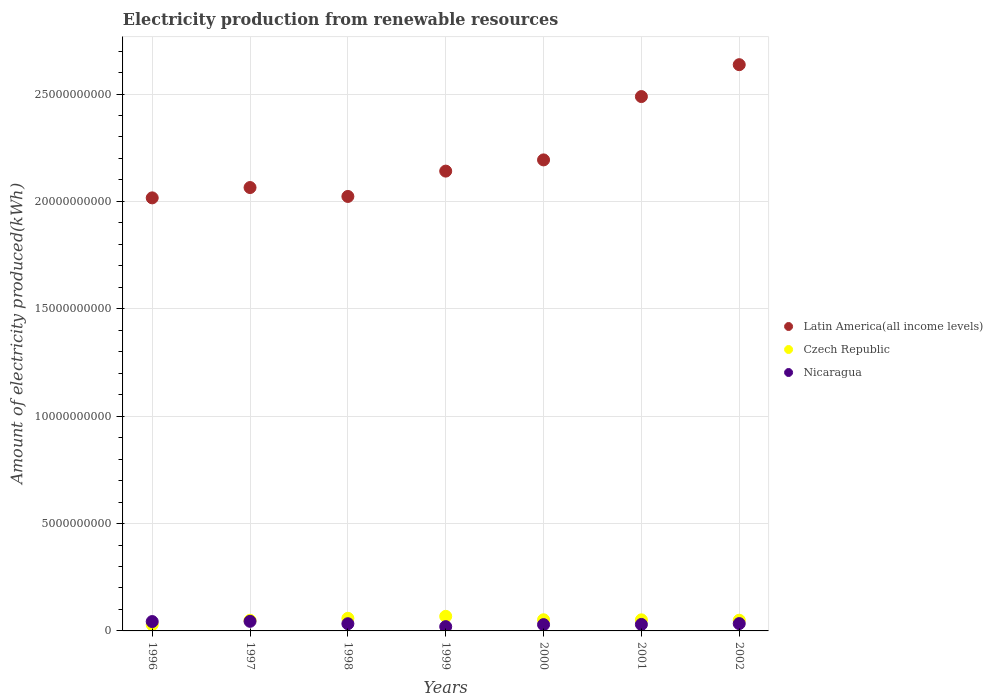What is the amount of electricity produced in Latin America(all income levels) in 1999?
Make the answer very short. 2.14e+1. Across all years, what is the maximum amount of electricity produced in Czech Republic?
Offer a terse response. 6.79e+08. Across all years, what is the minimum amount of electricity produced in Czech Republic?
Keep it short and to the point. 2.92e+08. In which year was the amount of electricity produced in Czech Republic maximum?
Keep it short and to the point. 1999. What is the total amount of electricity produced in Nicaragua in the graph?
Your answer should be compact. 2.35e+09. What is the difference between the amount of electricity produced in Latin America(all income levels) in 1999 and that in 2000?
Make the answer very short. -5.22e+08. What is the difference between the amount of electricity produced in Latin America(all income levels) in 2002 and the amount of electricity produced in Czech Republic in 1997?
Provide a succinct answer. 2.59e+1. What is the average amount of electricity produced in Nicaragua per year?
Give a very brief answer. 3.36e+08. In the year 1997, what is the difference between the amount of electricity produced in Latin America(all income levels) and amount of electricity produced in Nicaragua?
Your answer should be very brief. 2.02e+1. In how many years, is the amount of electricity produced in Latin America(all income levels) greater than 24000000000 kWh?
Your answer should be compact. 2. What is the ratio of the amount of electricity produced in Czech Republic in 1996 to that in 1997?
Give a very brief answer. 0.59. Is the amount of electricity produced in Latin America(all income levels) in 1997 less than that in 1999?
Keep it short and to the point. Yes. Is the difference between the amount of electricity produced in Latin America(all income levels) in 2000 and 2002 greater than the difference between the amount of electricity produced in Nicaragua in 2000 and 2002?
Provide a short and direct response. No. What is the difference between the highest and the second highest amount of electricity produced in Latin America(all income levels)?
Provide a short and direct response. 1.48e+09. What is the difference between the highest and the lowest amount of electricity produced in Latin America(all income levels)?
Keep it short and to the point. 6.20e+09. In how many years, is the amount of electricity produced in Nicaragua greater than the average amount of electricity produced in Nicaragua taken over all years?
Make the answer very short. 3. Is the sum of the amount of electricity produced in Czech Republic in 1996 and 1997 greater than the maximum amount of electricity produced in Latin America(all income levels) across all years?
Give a very brief answer. No. Does the amount of electricity produced in Nicaragua monotonically increase over the years?
Your response must be concise. No. Is the amount of electricity produced in Latin America(all income levels) strictly greater than the amount of electricity produced in Czech Republic over the years?
Make the answer very short. Yes. Is the amount of electricity produced in Nicaragua strictly less than the amount of electricity produced in Latin America(all income levels) over the years?
Your response must be concise. Yes. What is the difference between two consecutive major ticks on the Y-axis?
Keep it short and to the point. 5.00e+09. Where does the legend appear in the graph?
Make the answer very short. Center right. How many legend labels are there?
Provide a short and direct response. 3. How are the legend labels stacked?
Give a very brief answer. Vertical. What is the title of the graph?
Make the answer very short. Electricity production from renewable resources. What is the label or title of the Y-axis?
Make the answer very short. Amount of electricity produced(kWh). What is the Amount of electricity produced(kWh) in Latin America(all income levels) in 1996?
Your answer should be compact. 2.02e+1. What is the Amount of electricity produced(kWh) in Czech Republic in 1996?
Your response must be concise. 2.92e+08. What is the Amount of electricity produced(kWh) of Nicaragua in 1996?
Give a very brief answer. 4.36e+08. What is the Amount of electricity produced(kWh) of Latin America(all income levels) in 1997?
Offer a very short reply. 2.06e+1. What is the Amount of electricity produced(kWh) in Czech Republic in 1997?
Your response must be concise. 4.94e+08. What is the Amount of electricity produced(kWh) of Nicaragua in 1997?
Give a very brief answer. 4.47e+08. What is the Amount of electricity produced(kWh) of Latin America(all income levels) in 1998?
Your response must be concise. 2.02e+1. What is the Amount of electricity produced(kWh) of Czech Republic in 1998?
Your answer should be compact. 5.87e+08. What is the Amount of electricity produced(kWh) of Nicaragua in 1998?
Give a very brief answer. 3.35e+08. What is the Amount of electricity produced(kWh) of Latin America(all income levels) in 1999?
Your response must be concise. 2.14e+1. What is the Amount of electricity produced(kWh) in Czech Republic in 1999?
Provide a short and direct response. 6.79e+08. What is the Amount of electricity produced(kWh) in Latin America(all income levels) in 2000?
Keep it short and to the point. 2.19e+1. What is the Amount of electricity produced(kWh) in Czech Republic in 2000?
Offer a terse response. 5.19e+08. What is the Amount of electricity produced(kWh) of Nicaragua in 2000?
Your answer should be very brief. 2.93e+08. What is the Amount of electricity produced(kWh) in Latin America(all income levels) in 2001?
Your answer should be compact. 2.49e+1. What is the Amount of electricity produced(kWh) of Czech Republic in 2001?
Make the answer very short. 5.16e+08. What is the Amount of electricity produced(kWh) of Nicaragua in 2001?
Offer a very short reply. 3.02e+08. What is the Amount of electricity produced(kWh) in Latin America(all income levels) in 2002?
Give a very brief answer. 2.64e+1. What is the Amount of electricity produced(kWh) in Czech Republic in 2002?
Offer a terse response. 4.98e+08. What is the Amount of electricity produced(kWh) in Nicaragua in 2002?
Offer a terse response. 3.41e+08. Across all years, what is the maximum Amount of electricity produced(kWh) in Latin America(all income levels)?
Your answer should be compact. 2.64e+1. Across all years, what is the maximum Amount of electricity produced(kWh) in Czech Republic?
Keep it short and to the point. 6.79e+08. Across all years, what is the maximum Amount of electricity produced(kWh) of Nicaragua?
Give a very brief answer. 4.47e+08. Across all years, what is the minimum Amount of electricity produced(kWh) of Latin America(all income levels)?
Give a very brief answer. 2.02e+1. Across all years, what is the minimum Amount of electricity produced(kWh) of Czech Republic?
Your answer should be compact. 2.92e+08. Across all years, what is the minimum Amount of electricity produced(kWh) in Nicaragua?
Your answer should be compact. 2.00e+08. What is the total Amount of electricity produced(kWh) in Latin America(all income levels) in the graph?
Provide a succinct answer. 1.56e+11. What is the total Amount of electricity produced(kWh) of Czech Republic in the graph?
Provide a succinct answer. 3.58e+09. What is the total Amount of electricity produced(kWh) in Nicaragua in the graph?
Your response must be concise. 2.35e+09. What is the difference between the Amount of electricity produced(kWh) of Latin America(all income levels) in 1996 and that in 1997?
Ensure brevity in your answer.  -4.81e+08. What is the difference between the Amount of electricity produced(kWh) of Czech Republic in 1996 and that in 1997?
Provide a short and direct response. -2.02e+08. What is the difference between the Amount of electricity produced(kWh) of Nicaragua in 1996 and that in 1997?
Keep it short and to the point. -1.10e+07. What is the difference between the Amount of electricity produced(kWh) of Latin America(all income levels) in 1996 and that in 1998?
Give a very brief answer. -6.60e+07. What is the difference between the Amount of electricity produced(kWh) in Czech Republic in 1996 and that in 1998?
Give a very brief answer. -2.95e+08. What is the difference between the Amount of electricity produced(kWh) in Nicaragua in 1996 and that in 1998?
Your response must be concise. 1.01e+08. What is the difference between the Amount of electricity produced(kWh) in Latin America(all income levels) in 1996 and that in 1999?
Offer a very short reply. -1.25e+09. What is the difference between the Amount of electricity produced(kWh) of Czech Republic in 1996 and that in 1999?
Your response must be concise. -3.87e+08. What is the difference between the Amount of electricity produced(kWh) of Nicaragua in 1996 and that in 1999?
Provide a succinct answer. 2.36e+08. What is the difference between the Amount of electricity produced(kWh) in Latin America(all income levels) in 1996 and that in 2000?
Your answer should be compact. -1.77e+09. What is the difference between the Amount of electricity produced(kWh) of Czech Republic in 1996 and that in 2000?
Offer a terse response. -2.27e+08. What is the difference between the Amount of electricity produced(kWh) in Nicaragua in 1996 and that in 2000?
Provide a short and direct response. 1.43e+08. What is the difference between the Amount of electricity produced(kWh) of Latin America(all income levels) in 1996 and that in 2001?
Provide a short and direct response. -4.72e+09. What is the difference between the Amount of electricity produced(kWh) of Czech Republic in 1996 and that in 2001?
Offer a very short reply. -2.24e+08. What is the difference between the Amount of electricity produced(kWh) in Nicaragua in 1996 and that in 2001?
Your response must be concise. 1.34e+08. What is the difference between the Amount of electricity produced(kWh) of Latin America(all income levels) in 1996 and that in 2002?
Keep it short and to the point. -6.20e+09. What is the difference between the Amount of electricity produced(kWh) of Czech Republic in 1996 and that in 2002?
Provide a succinct answer. -2.06e+08. What is the difference between the Amount of electricity produced(kWh) in Nicaragua in 1996 and that in 2002?
Provide a succinct answer. 9.50e+07. What is the difference between the Amount of electricity produced(kWh) of Latin America(all income levels) in 1997 and that in 1998?
Offer a very short reply. 4.15e+08. What is the difference between the Amount of electricity produced(kWh) in Czech Republic in 1997 and that in 1998?
Your answer should be compact. -9.30e+07. What is the difference between the Amount of electricity produced(kWh) in Nicaragua in 1997 and that in 1998?
Your response must be concise. 1.12e+08. What is the difference between the Amount of electricity produced(kWh) of Latin America(all income levels) in 1997 and that in 1999?
Provide a short and direct response. -7.65e+08. What is the difference between the Amount of electricity produced(kWh) of Czech Republic in 1997 and that in 1999?
Offer a terse response. -1.85e+08. What is the difference between the Amount of electricity produced(kWh) in Nicaragua in 1997 and that in 1999?
Your answer should be very brief. 2.47e+08. What is the difference between the Amount of electricity produced(kWh) in Latin America(all income levels) in 1997 and that in 2000?
Your response must be concise. -1.29e+09. What is the difference between the Amount of electricity produced(kWh) of Czech Republic in 1997 and that in 2000?
Provide a succinct answer. -2.50e+07. What is the difference between the Amount of electricity produced(kWh) of Nicaragua in 1997 and that in 2000?
Ensure brevity in your answer.  1.54e+08. What is the difference between the Amount of electricity produced(kWh) in Latin America(all income levels) in 1997 and that in 2001?
Offer a terse response. -4.24e+09. What is the difference between the Amount of electricity produced(kWh) of Czech Republic in 1997 and that in 2001?
Your answer should be compact. -2.20e+07. What is the difference between the Amount of electricity produced(kWh) in Nicaragua in 1997 and that in 2001?
Your answer should be compact. 1.45e+08. What is the difference between the Amount of electricity produced(kWh) of Latin America(all income levels) in 1997 and that in 2002?
Offer a terse response. -5.72e+09. What is the difference between the Amount of electricity produced(kWh) in Nicaragua in 1997 and that in 2002?
Provide a succinct answer. 1.06e+08. What is the difference between the Amount of electricity produced(kWh) in Latin America(all income levels) in 1998 and that in 1999?
Your answer should be compact. -1.18e+09. What is the difference between the Amount of electricity produced(kWh) in Czech Republic in 1998 and that in 1999?
Offer a terse response. -9.20e+07. What is the difference between the Amount of electricity produced(kWh) of Nicaragua in 1998 and that in 1999?
Your answer should be very brief. 1.35e+08. What is the difference between the Amount of electricity produced(kWh) in Latin America(all income levels) in 1998 and that in 2000?
Your answer should be compact. -1.70e+09. What is the difference between the Amount of electricity produced(kWh) in Czech Republic in 1998 and that in 2000?
Your answer should be compact. 6.80e+07. What is the difference between the Amount of electricity produced(kWh) in Nicaragua in 1998 and that in 2000?
Your answer should be compact. 4.20e+07. What is the difference between the Amount of electricity produced(kWh) in Latin America(all income levels) in 1998 and that in 2001?
Provide a short and direct response. -4.65e+09. What is the difference between the Amount of electricity produced(kWh) in Czech Republic in 1998 and that in 2001?
Your answer should be very brief. 7.10e+07. What is the difference between the Amount of electricity produced(kWh) in Nicaragua in 1998 and that in 2001?
Keep it short and to the point. 3.30e+07. What is the difference between the Amount of electricity produced(kWh) in Latin America(all income levels) in 1998 and that in 2002?
Provide a short and direct response. -6.14e+09. What is the difference between the Amount of electricity produced(kWh) in Czech Republic in 1998 and that in 2002?
Your response must be concise. 8.90e+07. What is the difference between the Amount of electricity produced(kWh) in Nicaragua in 1998 and that in 2002?
Make the answer very short. -6.00e+06. What is the difference between the Amount of electricity produced(kWh) of Latin America(all income levels) in 1999 and that in 2000?
Provide a succinct answer. -5.22e+08. What is the difference between the Amount of electricity produced(kWh) of Czech Republic in 1999 and that in 2000?
Your answer should be very brief. 1.60e+08. What is the difference between the Amount of electricity produced(kWh) in Nicaragua in 1999 and that in 2000?
Your response must be concise. -9.30e+07. What is the difference between the Amount of electricity produced(kWh) in Latin America(all income levels) in 1999 and that in 2001?
Ensure brevity in your answer.  -3.47e+09. What is the difference between the Amount of electricity produced(kWh) of Czech Republic in 1999 and that in 2001?
Your answer should be compact. 1.63e+08. What is the difference between the Amount of electricity produced(kWh) in Nicaragua in 1999 and that in 2001?
Keep it short and to the point. -1.02e+08. What is the difference between the Amount of electricity produced(kWh) in Latin America(all income levels) in 1999 and that in 2002?
Offer a terse response. -4.96e+09. What is the difference between the Amount of electricity produced(kWh) of Czech Republic in 1999 and that in 2002?
Make the answer very short. 1.81e+08. What is the difference between the Amount of electricity produced(kWh) in Nicaragua in 1999 and that in 2002?
Make the answer very short. -1.41e+08. What is the difference between the Amount of electricity produced(kWh) of Latin America(all income levels) in 2000 and that in 2001?
Keep it short and to the point. -2.95e+09. What is the difference between the Amount of electricity produced(kWh) in Nicaragua in 2000 and that in 2001?
Keep it short and to the point. -9.00e+06. What is the difference between the Amount of electricity produced(kWh) in Latin America(all income levels) in 2000 and that in 2002?
Your answer should be very brief. -4.43e+09. What is the difference between the Amount of electricity produced(kWh) of Czech Republic in 2000 and that in 2002?
Make the answer very short. 2.10e+07. What is the difference between the Amount of electricity produced(kWh) in Nicaragua in 2000 and that in 2002?
Make the answer very short. -4.80e+07. What is the difference between the Amount of electricity produced(kWh) of Latin America(all income levels) in 2001 and that in 2002?
Keep it short and to the point. -1.48e+09. What is the difference between the Amount of electricity produced(kWh) of Czech Republic in 2001 and that in 2002?
Your answer should be compact. 1.80e+07. What is the difference between the Amount of electricity produced(kWh) in Nicaragua in 2001 and that in 2002?
Provide a succinct answer. -3.90e+07. What is the difference between the Amount of electricity produced(kWh) in Latin America(all income levels) in 1996 and the Amount of electricity produced(kWh) in Czech Republic in 1997?
Offer a very short reply. 1.97e+1. What is the difference between the Amount of electricity produced(kWh) in Latin America(all income levels) in 1996 and the Amount of electricity produced(kWh) in Nicaragua in 1997?
Make the answer very short. 1.97e+1. What is the difference between the Amount of electricity produced(kWh) in Czech Republic in 1996 and the Amount of electricity produced(kWh) in Nicaragua in 1997?
Give a very brief answer. -1.55e+08. What is the difference between the Amount of electricity produced(kWh) of Latin America(all income levels) in 1996 and the Amount of electricity produced(kWh) of Czech Republic in 1998?
Provide a short and direct response. 1.96e+1. What is the difference between the Amount of electricity produced(kWh) of Latin America(all income levels) in 1996 and the Amount of electricity produced(kWh) of Nicaragua in 1998?
Provide a succinct answer. 1.98e+1. What is the difference between the Amount of electricity produced(kWh) in Czech Republic in 1996 and the Amount of electricity produced(kWh) in Nicaragua in 1998?
Give a very brief answer. -4.30e+07. What is the difference between the Amount of electricity produced(kWh) in Latin America(all income levels) in 1996 and the Amount of electricity produced(kWh) in Czech Republic in 1999?
Provide a succinct answer. 1.95e+1. What is the difference between the Amount of electricity produced(kWh) of Latin America(all income levels) in 1996 and the Amount of electricity produced(kWh) of Nicaragua in 1999?
Your response must be concise. 2.00e+1. What is the difference between the Amount of electricity produced(kWh) in Czech Republic in 1996 and the Amount of electricity produced(kWh) in Nicaragua in 1999?
Ensure brevity in your answer.  9.20e+07. What is the difference between the Amount of electricity produced(kWh) of Latin America(all income levels) in 1996 and the Amount of electricity produced(kWh) of Czech Republic in 2000?
Make the answer very short. 1.96e+1. What is the difference between the Amount of electricity produced(kWh) in Latin America(all income levels) in 1996 and the Amount of electricity produced(kWh) in Nicaragua in 2000?
Ensure brevity in your answer.  1.99e+1. What is the difference between the Amount of electricity produced(kWh) in Latin America(all income levels) in 1996 and the Amount of electricity produced(kWh) in Czech Republic in 2001?
Your answer should be compact. 1.96e+1. What is the difference between the Amount of electricity produced(kWh) of Latin America(all income levels) in 1996 and the Amount of electricity produced(kWh) of Nicaragua in 2001?
Provide a succinct answer. 1.99e+1. What is the difference between the Amount of electricity produced(kWh) in Czech Republic in 1996 and the Amount of electricity produced(kWh) in Nicaragua in 2001?
Your response must be concise. -1.00e+07. What is the difference between the Amount of electricity produced(kWh) in Latin America(all income levels) in 1996 and the Amount of electricity produced(kWh) in Czech Republic in 2002?
Offer a very short reply. 1.97e+1. What is the difference between the Amount of electricity produced(kWh) in Latin America(all income levels) in 1996 and the Amount of electricity produced(kWh) in Nicaragua in 2002?
Offer a terse response. 1.98e+1. What is the difference between the Amount of electricity produced(kWh) in Czech Republic in 1996 and the Amount of electricity produced(kWh) in Nicaragua in 2002?
Give a very brief answer. -4.90e+07. What is the difference between the Amount of electricity produced(kWh) of Latin America(all income levels) in 1997 and the Amount of electricity produced(kWh) of Czech Republic in 1998?
Keep it short and to the point. 2.01e+1. What is the difference between the Amount of electricity produced(kWh) in Latin America(all income levels) in 1997 and the Amount of electricity produced(kWh) in Nicaragua in 1998?
Your answer should be compact. 2.03e+1. What is the difference between the Amount of electricity produced(kWh) in Czech Republic in 1997 and the Amount of electricity produced(kWh) in Nicaragua in 1998?
Offer a terse response. 1.59e+08. What is the difference between the Amount of electricity produced(kWh) of Latin America(all income levels) in 1997 and the Amount of electricity produced(kWh) of Czech Republic in 1999?
Offer a very short reply. 2.00e+1. What is the difference between the Amount of electricity produced(kWh) in Latin America(all income levels) in 1997 and the Amount of electricity produced(kWh) in Nicaragua in 1999?
Provide a short and direct response. 2.04e+1. What is the difference between the Amount of electricity produced(kWh) in Czech Republic in 1997 and the Amount of electricity produced(kWh) in Nicaragua in 1999?
Your answer should be very brief. 2.94e+08. What is the difference between the Amount of electricity produced(kWh) in Latin America(all income levels) in 1997 and the Amount of electricity produced(kWh) in Czech Republic in 2000?
Keep it short and to the point. 2.01e+1. What is the difference between the Amount of electricity produced(kWh) in Latin America(all income levels) in 1997 and the Amount of electricity produced(kWh) in Nicaragua in 2000?
Your response must be concise. 2.04e+1. What is the difference between the Amount of electricity produced(kWh) in Czech Republic in 1997 and the Amount of electricity produced(kWh) in Nicaragua in 2000?
Your answer should be very brief. 2.01e+08. What is the difference between the Amount of electricity produced(kWh) in Latin America(all income levels) in 1997 and the Amount of electricity produced(kWh) in Czech Republic in 2001?
Give a very brief answer. 2.01e+1. What is the difference between the Amount of electricity produced(kWh) of Latin America(all income levels) in 1997 and the Amount of electricity produced(kWh) of Nicaragua in 2001?
Ensure brevity in your answer.  2.03e+1. What is the difference between the Amount of electricity produced(kWh) in Czech Republic in 1997 and the Amount of electricity produced(kWh) in Nicaragua in 2001?
Provide a succinct answer. 1.92e+08. What is the difference between the Amount of electricity produced(kWh) of Latin America(all income levels) in 1997 and the Amount of electricity produced(kWh) of Czech Republic in 2002?
Make the answer very short. 2.01e+1. What is the difference between the Amount of electricity produced(kWh) of Latin America(all income levels) in 1997 and the Amount of electricity produced(kWh) of Nicaragua in 2002?
Offer a very short reply. 2.03e+1. What is the difference between the Amount of electricity produced(kWh) in Czech Republic in 1997 and the Amount of electricity produced(kWh) in Nicaragua in 2002?
Your response must be concise. 1.53e+08. What is the difference between the Amount of electricity produced(kWh) of Latin America(all income levels) in 1998 and the Amount of electricity produced(kWh) of Czech Republic in 1999?
Your answer should be compact. 1.96e+1. What is the difference between the Amount of electricity produced(kWh) in Latin America(all income levels) in 1998 and the Amount of electricity produced(kWh) in Nicaragua in 1999?
Ensure brevity in your answer.  2.00e+1. What is the difference between the Amount of electricity produced(kWh) in Czech Republic in 1998 and the Amount of electricity produced(kWh) in Nicaragua in 1999?
Your response must be concise. 3.87e+08. What is the difference between the Amount of electricity produced(kWh) in Latin America(all income levels) in 1998 and the Amount of electricity produced(kWh) in Czech Republic in 2000?
Your answer should be compact. 1.97e+1. What is the difference between the Amount of electricity produced(kWh) in Latin America(all income levels) in 1998 and the Amount of electricity produced(kWh) in Nicaragua in 2000?
Your response must be concise. 1.99e+1. What is the difference between the Amount of electricity produced(kWh) of Czech Republic in 1998 and the Amount of electricity produced(kWh) of Nicaragua in 2000?
Keep it short and to the point. 2.94e+08. What is the difference between the Amount of electricity produced(kWh) of Latin America(all income levels) in 1998 and the Amount of electricity produced(kWh) of Czech Republic in 2001?
Give a very brief answer. 1.97e+1. What is the difference between the Amount of electricity produced(kWh) in Latin America(all income levels) in 1998 and the Amount of electricity produced(kWh) in Nicaragua in 2001?
Provide a succinct answer. 1.99e+1. What is the difference between the Amount of electricity produced(kWh) of Czech Republic in 1998 and the Amount of electricity produced(kWh) of Nicaragua in 2001?
Your answer should be very brief. 2.85e+08. What is the difference between the Amount of electricity produced(kWh) of Latin America(all income levels) in 1998 and the Amount of electricity produced(kWh) of Czech Republic in 2002?
Offer a terse response. 1.97e+1. What is the difference between the Amount of electricity produced(kWh) of Latin America(all income levels) in 1998 and the Amount of electricity produced(kWh) of Nicaragua in 2002?
Your answer should be very brief. 1.99e+1. What is the difference between the Amount of electricity produced(kWh) of Czech Republic in 1998 and the Amount of electricity produced(kWh) of Nicaragua in 2002?
Keep it short and to the point. 2.46e+08. What is the difference between the Amount of electricity produced(kWh) of Latin America(all income levels) in 1999 and the Amount of electricity produced(kWh) of Czech Republic in 2000?
Your response must be concise. 2.09e+1. What is the difference between the Amount of electricity produced(kWh) in Latin America(all income levels) in 1999 and the Amount of electricity produced(kWh) in Nicaragua in 2000?
Your answer should be compact. 2.11e+1. What is the difference between the Amount of electricity produced(kWh) of Czech Republic in 1999 and the Amount of electricity produced(kWh) of Nicaragua in 2000?
Provide a succinct answer. 3.86e+08. What is the difference between the Amount of electricity produced(kWh) in Latin America(all income levels) in 1999 and the Amount of electricity produced(kWh) in Czech Republic in 2001?
Offer a terse response. 2.09e+1. What is the difference between the Amount of electricity produced(kWh) of Latin America(all income levels) in 1999 and the Amount of electricity produced(kWh) of Nicaragua in 2001?
Keep it short and to the point. 2.11e+1. What is the difference between the Amount of electricity produced(kWh) of Czech Republic in 1999 and the Amount of electricity produced(kWh) of Nicaragua in 2001?
Your answer should be very brief. 3.77e+08. What is the difference between the Amount of electricity produced(kWh) of Latin America(all income levels) in 1999 and the Amount of electricity produced(kWh) of Czech Republic in 2002?
Keep it short and to the point. 2.09e+1. What is the difference between the Amount of electricity produced(kWh) in Latin America(all income levels) in 1999 and the Amount of electricity produced(kWh) in Nicaragua in 2002?
Your answer should be compact. 2.11e+1. What is the difference between the Amount of electricity produced(kWh) in Czech Republic in 1999 and the Amount of electricity produced(kWh) in Nicaragua in 2002?
Provide a short and direct response. 3.38e+08. What is the difference between the Amount of electricity produced(kWh) in Latin America(all income levels) in 2000 and the Amount of electricity produced(kWh) in Czech Republic in 2001?
Your answer should be very brief. 2.14e+1. What is the difference between the Amount of electricity produced(kWh) of Latin America(all income levels) in 2000 and the Amount of electricity produced(kWh) of Nicaragua in 2001?
Offer a very short reply. 2.16e+1. What is the difference between the Amount of electricity produced(kWh) of Czech Republic in 2000 and the Amount of electricity produced(kWh) of Nicaragua in 2001?
Offer a terse response. 2.17e+08. What is the difference between the Amount of electricity produced(kWh) of Latin America(all income levels) in 2000 and the Amount of electricity produced(kWh) of Czech Republic in 2002?
Ensure brevity in your answer.  2.14e+1. What is the difference between the Amount of electricity produced(kWh) in Latin America(all income levels) in 2000 and the Amount of electricity produced(kWh) in Nicaragua in 2002?
Your answer should be very brief. 2.16e+1. What is the difference between the Amount of electricity produced(kWh) of Czech Republic in 2000 and the Amount of electricity produced(kWh) of Nicaragua in 2002?
Your answer should be very brief. 1.78e+08. What is the difference between the Amount of electricity produced(kWh) in Latin America(all income levels) in 2001 and the Amount of electricity produced(kWh) in Czech Republic in 2002?
Offer a very short reply. 2.44e+1. What is the difference between the Amount of electricity produced(kWh) in Latin America(all income levels) in 2001 and the Amount of electricity produced(kWh) in Nicaragua in 2002?
Your answer should be very brief. 2.45e+1. What is the difference between the Amount of electricity produced(kWh) in Czech Republic in 2001 and the Amount of electricity produced(kWh) in Nicaragua in 2002?
Give a very brief answer. 1.75e+08. What is the average Amount of electricity produced(kWh) of Latin America(all income levels) per year?
Your answer should be very brief. 2.22e+1. What is the average Amount of electricity produced(kWh) of Czech Republic per year?
Ensure brevity in your answer.  5.12e+08. What is the average Amount of electricity produced(kWh) of Nicaragua per year?
Keep it short and to the point. 3.36e+08. In the year 1996, what is the difference between the Amount of electricity produced(kWh) in Latin America(all income levels) and Amount of electricity produced(kWh) in Czech Republic?
Provide a short and direct response. 1.99e+1. In the year 1996, what is the difference between the Amount of electricity produced(kWh) of Latin America(all income levels) and Amount of electricity produced(kWh) of Nicaragua?
Offer a terse response. 1.97e+1. In the year 1996, what is the difference between the Amount of electricity produced(kWh) of Czech Republic and Amount of electricity produced(kWh) of Nicaragua?
Ensure brevity in your answer.  -1.44e+08. In the year 1997, what is the difference between the Amount of electricity produced(kWh) in Latin America(all income levels) and Amount of electricity produced(kWh) in Czech Republic?
Provide a succinct answer. 2.02e+1. In the year 1997, what is the difference between the Amount of electricity produced(kWh) of Latin America(all income levels) and Amount of electricity produced(kWh) of Nicaragua?
Provide a succinct answer. 2.02e+1. In the year 1997, what is the difference between the Amount of electricity produced(kWh) in Czech Republic and Amount of electricity produced(kWh) in Nicaragua?
Keep it short and to the point. 4.70e+07. In the year 1998, what is the difference between the Amount of electricity produced(kWh) of Latin America(all income levels) and Amount of electricity produced(kWh) of Czech Republic?
Provide a short and direct response. 1.96e+1. In the year 1998, what is the difference between the Amount of electricity produced(kWh) in Latin America(all income levels) and Amount of electricity produced(kWh) in Nicaragua?
Your answer should be very brief. 1.99e+1. In the year 1998, what is the difference between the Amount of electricity produced(kWh) in Czech Republic and Amount of electricity produced(kWh) in Nicaragua?
Provide a succinct answer. 2.52e+08. In the year 1999, what is the difference between the Amount of electricity produced(kWh) of Latin America(all income levels) and Amount of electricity produced(kWh) of Czech Republic?
Your response must be concise. 2.07e+1. In the year 1999, what is the difference between the Amount of electricity produced(kWh) in Latin America(all income levels) and Amount of electricity produced(kWh) in Nicaragua?
Your answer should be compact. 2.12e+1. In the year 1999, what is the difference between the Amount of electricity produced(kWh) in Czech Republic and Amount of electricity produced(kWh) in Nicaragua?
Offer a terse response. 4.79e+08. In the year 2000, what is the difference between the Amount of electricity produced(kWh) in Latin America(all income levels) and Amount of electricity produced(kWh) in Czech Republic?
Keep it short and to the point. 2.14e+1. In the year 2000, what is the difference between the Amount of electricity produced(kWh) of Latin America(all income levels) and Amount of electricity produced(kWh) of Nicaragua?
Keep it short and to the point. 2.16e+1. In the year 2000, what is the difference between the Amount of electricity produced(kWh) in Czech Republic and Amount of electricity produced(kWh) in Nicaragua?
Keep it short and to the point. 2.26e+08. In the year 2001, what is the difference between the Amount of electricity produced(kWh) of Latin America(all income levels) and Amount of electricity produced(kWh) of Czech Republic?
Your answer should be compact. 2.44e+1. In the year 2001, what is the difference between the Amount of electricity produced(kWh) in Latin America(all income levels) and Amount of electricity produced(kWh) in Nicaragua?
Give a very brief answer. 2.46e+1. In the year 2001, what is the difference between the Amount of electricity produced(kWh) of Czech Republic and Amount of electricity produced(kWh) of Nicaragua?
Your answer should be compact. 2.14e+08. In the year 2002, what is the difference between the Amount of electricity produced(kWh) in Latin America(all income levels) and Amount of electricity produced(kWh) in Czech Republic?
Ensure brevity in your answer.  2.59e+1. In the year 2002, what is the difference between the Amount of electricity produced(kWh) in Latin America(all income levels) and Amount of electricity produced(kWh) in Nicaragua?
Your answer should be compact. 2.60e+1. In the year 2002, what is the difference between the Amount of electricity produced(kWh) of Czech Republic and Amount of electricity produced(kWh) of Nicaragua?
Provide a short and direct response. 1.57e+08. What is the ratio of the Amount of electricity produced(kWh) in Latin America(all income levels) in 1996 to that in 1997?
Ensure brevity in your answer.  0.98. What is the ratio of the Amount of electricity produced(kWh) of Czech Republic in 1996 to that in 1997?
Provide a short and direct response. 0.59. What is the ratio of the Amount of electricity produced(kWh) in Nicaragua in 1996 to that in 1997?
Ensure brevity in your answer.  0.98. What is the ratio of the Amount of electricity produced(kWh) in Latin America(all income levels) in 1996 to that in 1998?
Offer a terse response. 1. What is the ratio of the Amount of electricity produced(kWh) in Czech Republic in 1996 to that in 1998?
Keep it short and to the point. 0.5. What is the ratio of the Amount of electricity produced(kWh) of Nicaragua in 1996 to that in 1998?
Keep it short and to the point. 1.3. What is the ratio of the Amount of electricity produced(kWh) of Latin America(all income levels) in 1996 to that in 1999?
Give a very brief answer. 0.94. What is the ratio of the Amount of electricity produced(kWh) of Czech Republic in 1996 to that in 1999?
Your answer should be very brief. 0.43. What is the ratio of the Amount of electricity produced(kWh) of Nicaragua in 1996 to that in 1999?
Your answer should be compact. 2.18. What is the ratio of the Amount of electricity produced(kWh) of Latin America(all income levels) in 1996 to that in 2000?
Your answer should be very brief. 0.92. What is the ratio of the Amount of electricity produced(kWh) in Czech Republic in 1996 to that in 2000?
Offer a very short reply. 0.56. What is the ratio of the Amount of electricity produced(kWh) in Nicaragua in 1996 to that in 2000?
Keep it short and to the point. 1.49. What is the ratio of the Amount of electricity produced(kWh) of Latin America(all income levels) in 1996 to that in 2001?
Provide a succinct answer. 0.81. What is the ratio of the Amount of electricity produced(kWh) of Czech Republic in 1996 to that in 2001?
Provide a short and direct response. 0.57. What is the ratio of the Amount of electricity produced(kWh) of Nicaragua in 1996 to that in 2001?
Your answer should be compact. 1.44. What is the ratio of the Amount of electricity produced(kWh) in Latin America(all income levels) in 1996 to that in 2002?
Offer a very short reply. 0.76. What is the ratio of the Amount of electricity produced(kWh) in Czech Republic in 1996 to that in 2002?
Your answer should be very brief. 0.59. What is the ratio of the Amount of electricity produced(kWh) of Nicaragua in 1996 to that in 2002?
Offer a very short reply. 1.28. What is the ratio of the Amount of electricity produced(kWh) in Latin America(all income levels) in 1997 to that in 1998?
Your answer should be compact. 1.02. What is the ratio of the Amount of electricity produced(kWh) in Czech Republic in 1997 to that in 1998?
Your answer should be compact. 0.84. What is the ratio of the Amount of electricity produced(kWh) in Nicaragua in 1997 to that in 1998?
Provide a succinct answer. 1.33. What is the ratio of the Amount of electricity produced(kWh) in Latin America(all income levels) in 1997 to that in 1999?
Offer a very short reply. 0.96. What is the ratio of the Amount of electricity produced(kWh) in Czech Republic in 1997 to that in 1999?
Offer a very short reply. 0.73. What is the ratio of the Amount of electricity produced(kWh) in Nicaragua in 1997 to that in 1999?
Give a very brief answer. 2.23. What is the ratio of the Amount of electricity produced(kWh) of Latin America(all income levels) in 1997 to that in 2000?
Provide a short and direct response. 0.94. What is the ratio of the Amount of electricity produced(kWh) in Czech Republic in 1997 to that in 2000?
Offer a terse response. 0.95. What is the ratio of the Amount of electricity produced(kWh) of Nicaragua in 1997 to that in 2000?
Your answer should be very brief. 1.53. What is the ratio of the Amount of electricity produced(kWh) of Latin America(all income levels) in 1997 to that in 2001?
Your answer should be compact. 0.83. What is the ratio of the Amount of electricity produced(kWh) in Czech Republic in 1997 to that in 2001?
Offer a very short reply. 0.96. What is the ratio of the Amount of electricity produced(kWh) of Nicaragua in 1997 to that in 2001?
Your response must be concise. 1.48. What is the ratio of the Amount of electricity produced(kWh) of Latin America(all income levels) in 1997 to that in 2002?
Keep it short and to the point. 0.78. What is the ratio of the Amount of electricity produced(kWh) of Nicaragua in 1997 to that in 2002?
Provide a short and direct response. 1.31. What is the ratio of the Amount of electricity produced(kWh) of Latin America(all income levels) in 1998 to that in 1999?
Ensure brevity in your answer.  0.94. What is the ratio of the Amount of electricity produced(kWh) of Czech Republic in 1998 to that in 1999?
Ensure brevity in your answer.  0.86. What is the ratio of the Amount of electricity produced(kWh) in Nicaragua in 1998 to that in 1999?
Make the answer very short. 1.68. What is the ratio of the Amount of electricity produced(kWh) of Latin America(all income levels) in 1998 to that in 2000?
Make the answer very short. 0.92. What is the ratio of the Amount of electricity produced(kWh) in Czech Republic in 1998 to that in 2000?
Your answer should be very brief. 1.13. What is the ratio of the Amount of electricity produced(kWh) in Nicaragua in 1998 to that in 2000?
Provide a succinct answer. 1.14. What is the ratio of the Amount of electricity produced(kWh) in Latin America(all income levels) in 1998 to that in 2001?
Give a very brief answer. 0.81. What is the ratio of the Amount of electricity produced(kWh) of Czech Republic in 1998 to that in 2001?
Your answer should be very brief. 1.14. What is the ratio of the Amount of electricity produced(kWh) of Nicaragua in 1998 to that in 2001?
Your answer should be very brief. 1.11. What is the ratio of the Amount of electricity produced(kWh) of Latin America(all income levels) in 1998 to that in 2002?
Offer a terse response. 0.77. What is the ratio of the Amount of electricity produced(kWh) of Czech Republic in 1998 to that in 2002?
Ensure brevity in your answer.  1.18. What is the ratio of the Amount of electricity produced(kWh) in Nicaragua in 1998 to that in 2002?
Give a very brief answer. 0.98. What is the ratio of the Amount of electricity produced(kWh) in Latin America(all income levels) in 1999 to that in 2000?
Make the answer very short. 0.98. What is the ratio of the Amount of electricity produced(kWh) of Czech Republic in 1999 to that in 2000?
Your answer should be very brief. 1.31. What is the ratio of the Amount of electricity produced(kWh) in Nicaragua in 1999 to that in 2000?
Provide a succinct answer. 0.68. What is the ratio of the Amount of electricity produced(kWh) of Latin America(all income levels) in 1999 to that in 2001?
Provide a succinct answer. 0.86. What is the ratio of the Amount of electricity produced(kWh) of Czech Republic in 1999 to that in 2001?
Your answer should be very brief. 1.32. What is the ratio of the Amount of electricity produced(kWh) of Nicaragua in 1999 to that in 2001?
Ensure brevity in your answer.  0.66. What is the ratio of the Amount of electricity produced(kWh) in Latin America(all income levels) in 1999 to that in 2002?
Provide a succinct answer. 0.81. What is the ratio of the Amount of electricity produced(kWh) of Czech Republic in 1999 to that in 2002?
Offer a terse response. 1.36. What is the ratio of the Amount of electricity produced(kWh) in Nicaragua in 1999 to that in 2002?
Make the answer very short. 0.59. What is the ratio of the Amount of electricity produced(kWh) in Latin America(all income levels) in 2000 to that in 2001?
Ensure brevity in your answer.  0.88. What is the ratio of the Amount of electricity produced(kWh) of Nicaragua in 2000 to that in 2001?
Your response must be concise. 0.97. What is the ratio of the Amount of electricity produced(kWh) of Latin America(all income levels) in 2000 to that in 2002?
Offer a terse response. 0.83. What is the ratio of the Amount of electricity produced(kWh) in Czech Republic in 2000 to that in 2002?
Ensure brevity in your answer.  1.04. What is the ratio of the Amount of electricity produced(kWh) in Nicaragua in 2000 to that in 2002?
Ensure brevity in your answer.  0.86. What is the ratio of the Amount of electricity produced(kWh) of Latin America(all income levels) in 2001 to that in 2002?
Make the answer very short. 0.94. What is the ratio of the Amount of electricity produced(kWh) of Czech Republic in 2001 to that in 2002?
Make the answer very short. 1.04. What is the ratio of the Amount of electricity produced(kWh) of Nicaragua in 2001 to that in 2002?
Your response must be concise. 0.89. What is the difference between the highest and the second highest Amount of electricity produced(kWh) in Latin America(all income levels)?
Give a very brief answer. 1.48e+09. What is the difference between the highest and the second highest Amount of electricity produced(kWh) in Czech Republic?
Offer a very short reply. 9.20e+07. What is the difference between the highest and the second highest Amount of electricity produced(kWh) of Nicaragua?
Give a very brief answer. 1.10e+07. What is the difference between the highest and the lowest Amount of electricity produced(kWh) of Latin America(all income levels)?
Make the answer very short. 6.20e+09. What is the difference between the highest and the lowest Amount of electricity produced(kWh) in Czech Republic?
Your answer should be very brief. 3.87e+08. What is the difference between the highest and the lowest Amount of electricity produced(kWh) in Nicaragua?
Offer a very short reply. 2.47e+08. 